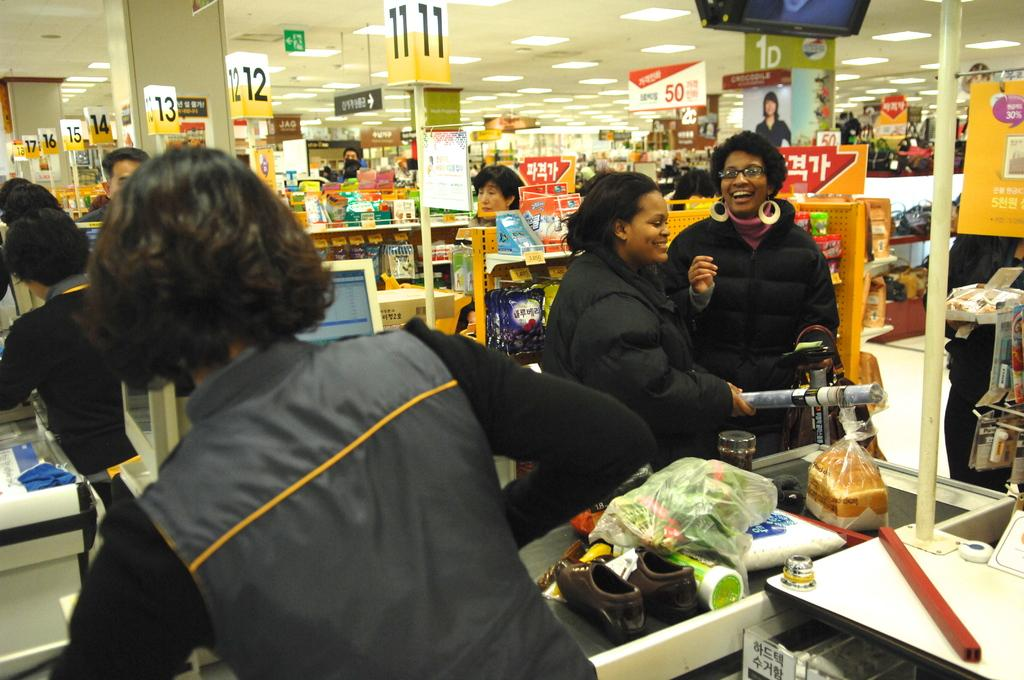<image>
Summarize the visual content of the image. some people in a store with the number 11 near them 